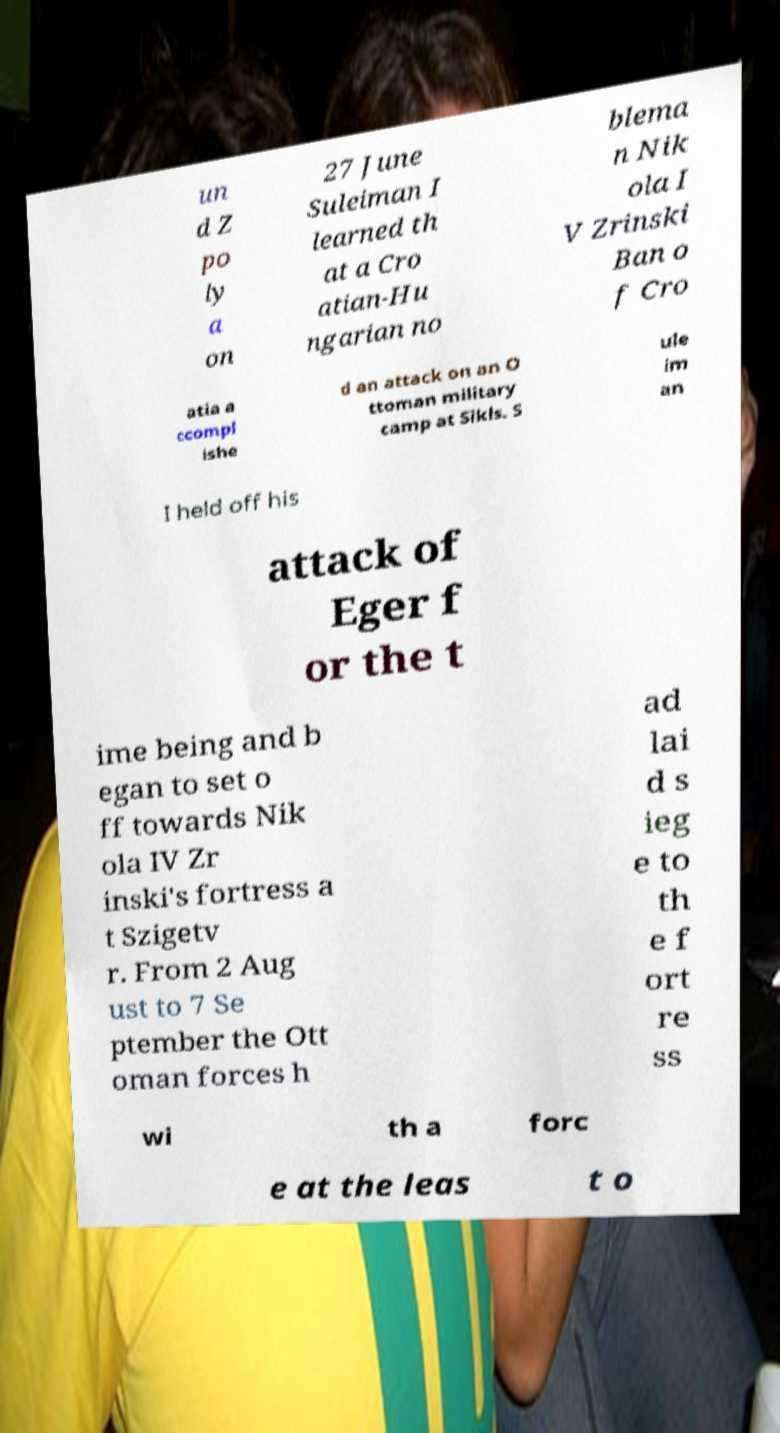Could you assist in decoding the text presented in this image and type it out clearly? un d Z po ly a on 27 June Suleiman I learned th at a Cro atian-Hu ngarian no blema n Nik ola I V Zrinski Ban o f Cro atia a ccompl ishe d an attack on an O ttoman military camp at Sikls. S ule im an I held off his attack of Eger f or the t ime being and b egan to set o ff towards Nik ola IV Zr inski's fortress a t Szigetv r. From 2 Aug ust to 7 Se ptember the Ott oman forces h ad lai d s ieg e to th e f ort re ss wi th a forc e at the leas t o 